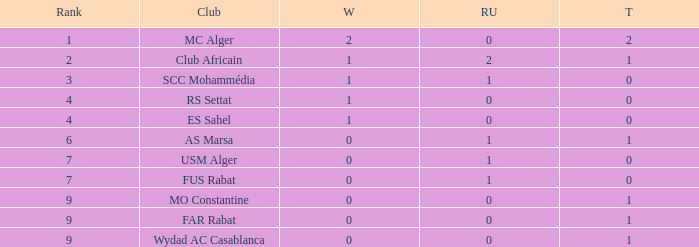Which Third has Runners-up of 0, and Winners of 0, and a Club of far rabat? 1.0. 